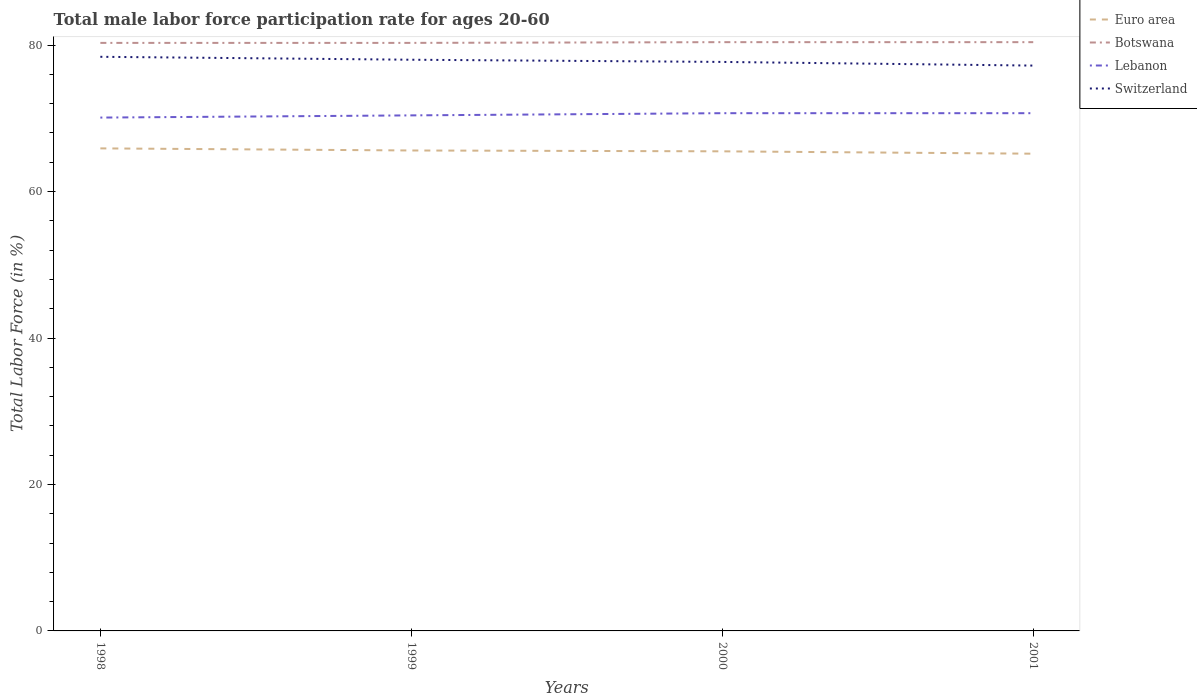How many different coloured lines are there?
Give a very brief answer. 4. Is the number of lines equal to the number of legend labels?
Your response must be concise. Yes. Across all years, what is the maximum male labor force participation rate in Switzerland?
Make the answer very short. 77.2. What is the total male labor force participation rate in Euro area in the graph?
Your answer should be very brief. 0.12. What is the difference between the highest and the second highest male labor force participation rate in Switzerland?
Offer a very short reply. 1.2. What is the difference between the highest and the lowest male labor force participation rate in Botswana?
Ensure brevity in your answer.  2. Is the male labor force participation rate in Euro area strictly greater than the male labor force participation rate in Switzerland over the years?
Keep it short and to the point. Yes. How many lines are there?
Provide a short and direct response. 4. Does the graph contain any zero values?
Your answer should be very brief. No. Where does the legend appear in the graph?
Offer a very short reply. Top right. What is the title of the graph?
Provide a succinct answer. Total male labor force participation rate for ages 20-60. What is the Total Labor Force (in %) of Euro area in 1998?
Offer a very short reply. 65.89. What is the Total Labor Force (in %) in Botswana in 1998?
Make the answer very short. 80.3. What is the Total Labor Force (in %) in Lebanon in 1998?
Offer a very short reply. 70.1. What is the Total Labor Force (in %) of Switzerland in 1998?
Ensure brevity in your answer.  78.4. What is the Total Labor Force (in %) in Euro area in 1999?
Your answer should be compact. 65.61. What is the Total Labor Force (in %) in Botswana in 1999?
Provide a succinct answer. 80.3. What is the Total Labor Force (in %) of Lebanon in 1999?
Your answer should be compact. 70.4. What is the Total Labor Force (in %) of Euro area in 2000?
Make the answer very short. 65.49. What is the Total Labor Force (in %) of Botswana in 2000?
Your response must be concise. 80.4. What is the Total Labor Force (in %) of Lebanon in 2000?
Ensure brevity in your answer.  70.7. What is the Total Labor Force (in %) of Switzerland in 2000?
Offer a very short reply. 77.7. What is the Total Labor Force (in %) of Euro area in 2001?
Ensure brevity in your answer.  65.17. What is the Total Labor Force (in %) in Botswana in 2001?
Your response must be concise. 80.4. What is the Total Labor Force (in %) in Lebanon in 2001?
Your response must be concise. 70.7. What is the Total Labor Force (in %) in Switzerland in 2001?
Provide a succinct answer. 77.2. Across all years, what is the maximum Total Labor Force (in %) of Euro area?
Your response must be concise. 65.89. Across all years, what is the maximum Total Labor Force (in %) of Botswana?
Your answer should be very brief. 80.4. Across all years, what is the maximum Total Labor Force (in %) in Lebanon?
Your response must be concise. 70.7. Across all years, what is the maximum Total Labor Force (in %) of Switzerland?
Offer a terse response. 78.4. Across all years, what is the minimum Total Labor Force (in %) in Euro area?
Provide a succinct answer. 65.17. Across all years, what is the minimum Total Labor Force (in %) in Botswana?
Your response must be concise. 80.3. Across all years, what is the minimum Total Labor Force (in %) of Lebanon?
Offer a very short reply. 70.1. Across all years, what is the minimum Total Labor Force (in %) in Switzerland?
Ensure brevity in your answer.  77.2. What is the total Total Labor Force (in %) in Euro area in the graph?
Make the answer very short. 262.16. What is the total Total Labor Force (in %) in Botswana in the graph?
Your answer should be compact. 321.4. What is the total Total Labor Force (in %) of Lebanon in the graph?
Keep it short and to the point. 281.9. What is the total Total Labor Force (in %) in Switzerland in the graph?
Offer a very short reply. 311.3. What is the difference between the Total Labor Force (in %) in Euro area in 1998 and that in 1999?
Your answer should be compact. 0.29. What is the difference between the Total Labor Force (in %) of Botswana in 1998 and that in 1999?
Your response must be concise. 0. What is the difference between the Total Labor Force (in %) in Switzerland in 1998 and that in 1999?
Offer a terse response. 0.4. What is the difference between the Total Labor Force (in %) in Euro area in 1998 and that in 2000?
Offer a terse response. 0.4. What is the difference between the Total Labor Force (in %) of Switzerland in 1998 and that in 2000?
Make the answer very short. 0.7. What is the difference between the Total Labor Force (in %) of Euro area in 1998 and that in 2001?
Your response must be concise. 0.73. What is the difference between the Total Labor Force (in %) of Botswana in 1998 and that in 2001?
Ensure brevity in your answer.  -0.1. What is the difference between the Total Labor Force (in %) of Switzerland in 1998 and that in 2001?
Give a very brief answer. 1.2. What is the difference between the Total Labor Force (in %) of Euro area in 1999 and that in 2000?
Your response must be concise. 0.12. What is the difference between the Total Labor Force (in %) of Switzerland in 1999 and that in 2000?
Keep it short and to the point. 0.3. What is the difference between the Total Labor Force (in %) in Euro area in 1999 and that in 2001?
Give a very brief answer. 0.44. What is the difference between the Total Labor Force (in %) in Botswana in 1999 and that in 2001?
Offer a terse response. -0.1. What is the difference between the Total Labor Force (in %) of Lebanon in 1999 and that in 2001?
Offer a terse response. -0.3. What is the difference between the Total Labor Force (in %) in Euro area in 2000 and that in 2001?
Offer a very short reply. 0.32. What is the difference between the Total Labor Force (in %) in Botswana in 2000 and that in 2001?
Ensure brevity in your answer.  0. What is the difference between the Total Labor Force (in %) of Lebanon in 2000 and that in 2001?
Provide a short and direct response. 0. What is the difference between the Total Labor Force (in %) of Euro area in 1998 and the Total Labor Force (in %) of Botswana in 1999?
Your response must be concise. -14.41. What is the difference between the Total Labor Force (in %) of Euro area in 1998 and the Total Labor Force (in %) of Lebanon in 1999?
Provide a short and direct response. -4.51. What is the difference between the Total Labor Force (in %) of Euro area in 1998 and the Total Labor Force (in %) of Switzerland in 1999?
Provide a short and direct response. -12.11. What is the difference between the Total Labor Force (in %) of Botswana in 1998 and the Total Labor Force (in %) of Lebanon in 1999?
Your response must be concise. 9.9. What is the difference between the Total Labor Force (in %) in Lebanon in 1998 and the Total Labor Force (in %) in Switzerland in 1999?
Your answer should be compact. -7.9. What is the difference between the Total Labor Force (in %) in Euro area in 1998 and the Total Labor Force (in %) in Botswana in 2000?
Your answer should be compact. -14.51. What is the difference between the Total Labor Force (in %) in Euro area in 1998 and the Total Labor Force (in %) in Lebanon in 2000?
Give a very brief answer. -4.81. What is the difference between the Total Labor Force (in %) in Euro area in 1998 and the Total Labor Force (in %) in Switzerland in 2000?
Provide a succinct answer. -11.81. What is the difference between the Total Labor Force (in %) in Botswana in 1998 and the Total Labor Force (in %) in Lebanon in 2000?
Keep it short and to the point. 9.6. What is the difference between the Total Labor Force (in %) in Lebanon in 1998 and the Total Labor Force (in %) in Switzerland in 2000?
Ensure brevity in your answer.  -7.6. What is the difference between the Total Labor Force (in %) of Euro area in 1998 and the Total Labor Force (in %) of Botswana in 2001?
Ensure brevity in your answer.  -14.51. What is the difference between the Total Labor Force (in %) in Euro area in 1998 and the Total Labor Force (in %) in Lebanon in 2001?
Give a very brief answer. -4.81. What is the difference between the Total Labor Force (in %) of Euro area in 1998 and the Total Labor Force (in %) of Switzerland in 2001?
Give a very brief answer. -11.31. What is the difference between the Total Labor Force (in %) of Botswana in 1998 and the Total Labor Force (in %) of Lebanon in 2001?
Ensure brevity in your answer.  9.6. What is the difference between the Total Labor Force (in %) of Botswana in 1998 and the Total Labor Force (in %) of Switzerland in 2001?
Give a very brief answer. 3.1. What is the difference between the Total Labor Force (in %) in Lebanon in 1998 and the Total Labor Force (in %) in Switzerland in 2001?
Provide a succinct answer. -7.1. What is the difference between the Total Labor Force (in %) of Euro area in 1999 and the Total Labor Force (in %) of Botswana in 2000?
Your response must be concise. -14.79. What is the difference between the Total Labor Force (in %) in Euro area in 1999 and the Total Labor Force (in %) in Lebanon in 2000?
Keep it short and to the point. -5.09. What is the difference between the Total Labor Force (in %) in Euro area in 1999 and the Total Labor Force (in %) in Switzerland in 2000?
Your answer should be compact. -12.09. What is the difference between the Total Labor Force (in %) of Botswana in 1999 and the Total Labor Force (in %) of Lebanon in 2000?
Your response must be concise. 9.6. What is the difference between the Total Labor Force (in %) in Euro area in 1999 and the Total Labor Force (in %) in Botswana in 2001?
Offer a terse response. -14.79. What is the difference between the Total Labor Force (in %) in Euro area in 1999 and the Total Labor Force (in %) in Lebanon in 2001?
Your answer should be compact. -5.09. What is the difference between the Total Labor Force (in %) in Euro area in 1999 and the Total Labor Force (in %) in Switzerland in 2001?
Your answer should be compact. -11.59. What is the difference between the Total Labor Force (in %) of Botswana in 1999 and the Total Labor Force (in %) of Lebanon in 2001?
Your answer should be very brief. 9.6. What is the difference between the Total Labor Force (in %) in Lebanon in 1999 and the Total Labor Force (in %) in Switzerland in 2001?
Give a very brief answer. -6.8. What is the difference between the Total Labor Force (in %) in Euro area in 2000 and the Total Labor Force (in %) in Botswana in 2001?
Offer a very short reply. -14.91. What is the difference between the Total Labor Force (in %) in Euro area in 2000 and the Total Labor Force (in %) in Lebanon in 2001?
Ensure brevity in your answer.  -5.21. What is the difference between the Total Labor Force (in %) of Euro area in 2000 and the Total Labor Force (in %) of Switzerland in 2001?
Your answer should be very brief. -11.71. What is the difference between the Total Labor Force (in %) of Botswana in 2000 and the Total Labor Force (in %) of Lebanon in 2001?
Your answer should be compact. 9.7. What is the difference between the Total Labor Force (in %) in Botswana in 2000 and the Total Labor Force (in %) in Switzerland in 2001?
Provide a succinct answer. 3.2. What is the difference between the Total Labor Force (in %) in Lebanon in 2000 and the Total Labor Force (in %) in Switzerland in 2001?
Keep it short and to the point. -6.5. What is the average Total Labor Force (in %) of Euro area per year?
Offer a very short reply. 65.54. What is the average Total Labor Force (in %) of Botswana per year?
Offer a terse response. 80.35. What is the average Total Labor Force (in %) of Lebanon per year?
Your answer should be compact. 70.47. What is the average Total Labor Force (in %) in Switzerland per year?
Give a very brief answer. 77.83. In the year 1998, what is the difference between the Total Labor Force (in %) of Euro area and Total Labor Force (in %) of Botswana?
Keep it short and to the point. -14.41. In the year 1998, what is the difference between the Total Labor Force (in %) in Euro area and Total Labor Force (in %) in Lebanon?
Offer a very short reply. -4.21. In the year 1998, what is the difference between the Total Labor Force (in %) of Euro area and Total Labor Force (in %) of Switzerland?
Provide a short and direct response. -12.51. In the year 1998, what is the difference between the Total Labor Force (in %) in Botswana and Total Labor Force (in %) in Switzerland?
Keep it short and to the point. 1.9. In the year 1999, what is the difference between the Total Labor Force (in %) in Euro area and Total Labor Force (in %) in Botswana?
Keep it short and to the point. -14.69. In the year 1999, what is the difference between the Total Labor Force (in %) in Euro area and Total Labor Force (in %) in Lebanon?
Your answer should be compact. -4.79. In the year 1999, what is the difference between the Total Labor Force (in %) in Euro area and Total Labor Force (in %) in Switzerland?
Your answer should be compact. -12.39. In the year 1999, what is the difference between the Total Labor Force (in %) in Lebanon and Total Labor Force (in %) in Switzerland?
Provide a succinct answer. -7.6. In the year 2000, what is the difference between the Total Labor Force (in %) of Euro area and Total Labor Force (in %) of Botswana?
Your answer should be compact. -14.91. In the year 2000, what is the difference between the Total Labor Force (in %) of Euro area and Total Labor Force (in %) of Lebanon?
Your response must be concise. -5.21. In the year 2000, what is the difference between the Total Labor Force (in %) in Euro area and Total Labor Force (in %) in Switzerland?
Your answer should be compact. -12.21. In the year 2000, what is the difference between the Total Labor Force (in %) of Lebanon and Total Labor Force (in %) of Switzerland?
Your answer should be compact. -7. In the year 2001, what is the difference between the Total Labor Force (in %) of Euro area and Total Labor Force (in %) of Botswana?
Keep it short and to the point. -15.23. In the year 2001, what is the difference between the Total Labor Force (in %) of Euro area and Total Labor Force (in %) of Lebanon?
Offer a very short reply. -5.53. In the year 2001, what is the difference between the Total Labor Force (in %) in Euro area and Total Labor Force (in %) in Switzerland?
Offer a very short reply. -12.03. In the year 2001, what is the difference between the Total Labor Force (in %) of Botswana and Total Labor Force (in %) of Lebanon?
Provide a succinct answer. 9.7. In the year 2001, what is the difference between the Total Labor Force (in %) of Botswana and Total Labor Force (in %) of Switzerland?
Provide a succinct answer. 3.2. In the year 2001, what is the difference between the Total Labor Force (in %) in Lebanon and Total Labor Force (in %) in Switzerland?
Make the answer very short. -6.5. What is the ratio of the Total Labor Force (in %) of Lebanon in 1998 to that in 1999?
Ensure brevity in your answer.  1. What is the ratio of the Total Labor Force (in %) of Euro area in 1998 to that in 2000?
Ensure brevity in your answer.  1.01. What is the ratio of the Total Labor Force (in %) in Switzerland in 1998 to that in 2000?
Make the answer very short. 1.01. What is the ratio of the Total Labor Force (in %) of Euro area in 1998 to that in 2001?
Give a very brief answer. 1.01. What is the ratio of the Total Labor Force (in %) of Botswana in 1998 to that in 2001?
Your answer should be compact. 1. What is the ratio of the Total Labor Force (in %) in Lebanon in 1998 to that in 2001?
Offer a terse response. 0.99. What is the ratio of the Total Labor Force (in %) of Switzerland in 1998 to that in 2001?
Keep it short and to the point. 1.02. What is the ratio of the Total Labor Force (in %) in Euro area in 1999 to that in 2000?
Your answer should be very brief. 1. What is the ratio of the Total Labor Force (in %) of Botswana in 1999 to that in 2000?
Provide a short and direct response. 1. What is the ratio of the Total Labor Force (in %) of Switzerland in 1999 to that in 2000?
Your answer should be compact. 1. What is the ratio of the Total Labor Force (in %) of Euro area in 1999 to that in 2001?
Your response must be concise. 1.01. What is the ratio of the Total Labor Force (in %) of Botswana in 1999 to that in 2001?
Your answer should be very brief. 1. What is the ratio of the Total Labor Force (in %) in Lebanon in 1999 to that in 2001?
Offer a very short reply. 1. What is the ratio of the Total Labor Force (in %) in Switzerland in 1999 to that in 2001?
Ensure brevity in your answer.  1.01. What is the ratio of the Total Labor Force (in %) in Euro area in 2000 to that in 2001?
Ensure brevity in your answer.  1. What is the ratio of the Total Labor Force (in %) in Lebanon in 2000 to that in 2001?
Provide a succinct answer. 1. What is the ratio of the Total Labor Force (in %) of Switzerland in 2000 to that in 2001?
Offer a terse response. 1.01. What is the difference between the highest and the second highest Total Labor Force (in %) in Euro area?
Your answer should be very brief. 0.29. What is the difference between the highest and the second highest Total Labor Force (in %) in Lebanon?
Ensure brevity in your answer.  0. What is the difference between the highest and the lowest Total Labor Force (in %) of Euro area?
Provide a short and direct response. 0.73. What is the difference between the highest and the lowest Total Labor Force (in %) of Botswana?
Offer a terse response. 0.1. What is the difference between the highest and the lowest Total Labor Force (in %) of Lebanon?
Provide a short and direct response. 0.6. What is the difference between the highest and the lowest Total Labor Force (in %) in Switzerland?
Offer a terse response. 1.2. 